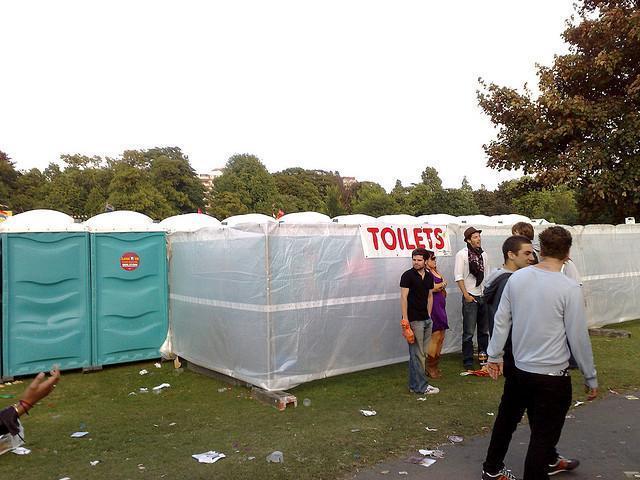How many toilets are in the photo?
Give a very brief answer. 2. How many people are in the photo?
Give a very brief answer. 4. 